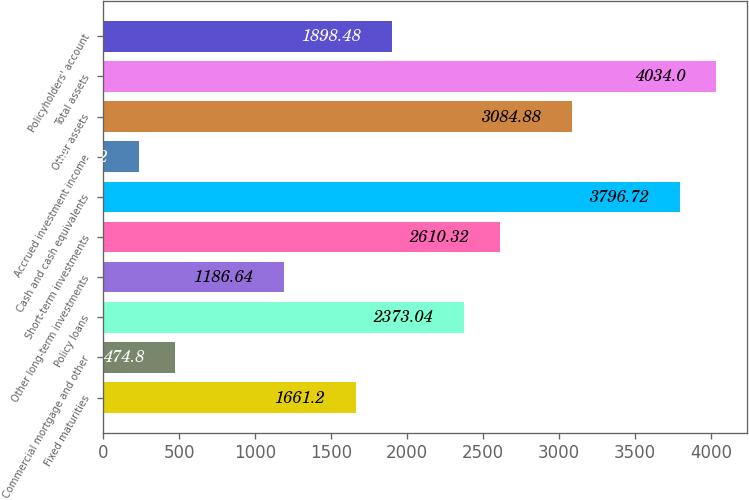Convert chart. <chart><loc_0><loc_0><loc_500><loc_500><bar_chart><fcel>Fixed maturities<fcel>Commercial mortgage and other<fcel>Policy loans<fcel>Other long-term investments<fcel>Short-term investments<fcel>Cash and cash equivalents<fcel>Accrued investment income<fcel>Other assets<fcel>Total assets<fcel>Policyholders' account<nl><fcel>1661.2<fcel>474.8<fcel>2373.04<fcel>1186.64<fcel>2610.32<fcel>3796.72<fcel>237.52<fcel>3084.88<fcel>4034<fcel>1898.48<nl></chart> 